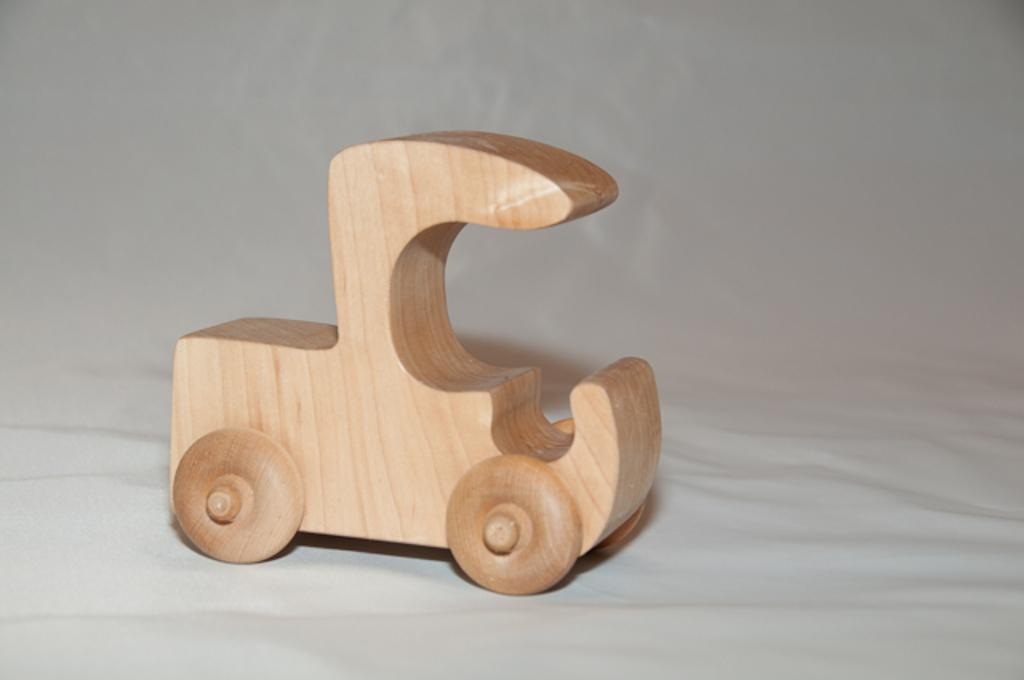What type of toy is in the image? There is a wooden toy in the image. What is the toy placed on? The wooden toy is on a white surface. How many marbles are resting on the wooden toy in the image? There are no marbles present in the image; it only features a wooden toy on a white surface. 